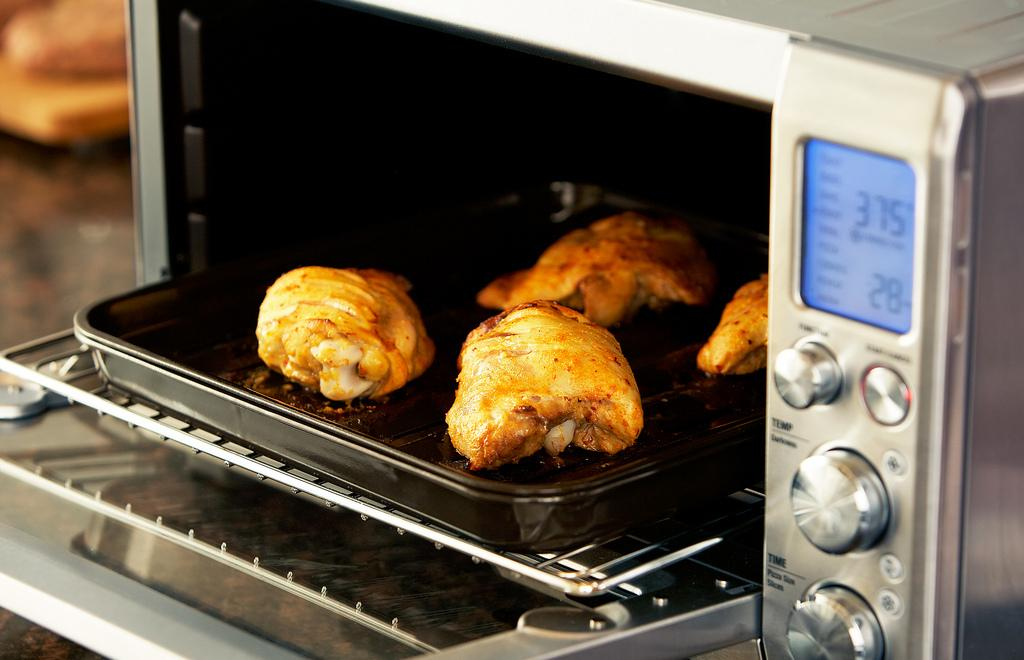<image>
Offer a succinct explanation of the picture presented. an oven with 375 written on the side 